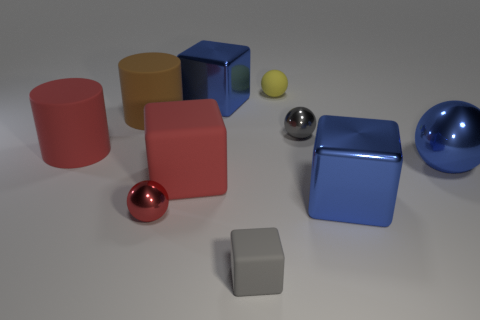The large blue object behind the gray metal ball has what shape?
Your answer should be compact. Cube. How many things are yellow matte spheres or blocks that are in front of the blue metallic sphere?
Offer a terse response. 4. Does the blue sphere have the same material as the large brown thing?
Give a very brief answer. No. Are there an equal number of cubes that are behind the large blue sphere and small matte blocks to the left of the small cube?
Offer a very short reply. No. What number of gray spheres are to the left of the brown object?
Offer a terse response. 0. What number of things are either large rubber blocks or red spheres?
Make the answer very short. 2. How many rubber things have the same size as the red matte block?
Provide a succinct answer. 2. What shape is the big red thing on the left side of the big red thing right of the red metallic sphere?
Keep it short and to the point. Cylinder. Is the number of big cyan metallic balls less than the number of big blue metallic objects?
Offer a terse response. Yes. There is a tiny metal sphere behind the large rubber block; what is its color?
Offer a very short reply. Gray. 